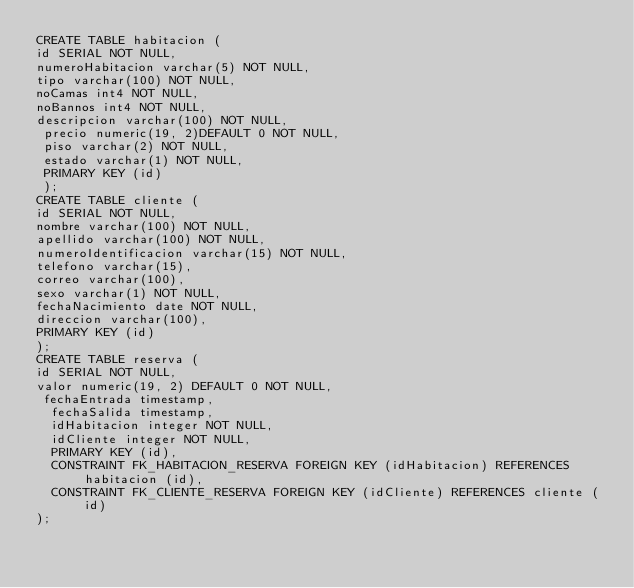<code> <loc_0><loc_0><loc_500><loc_500><_SQL_>CREATE TABLE habitacion (
id SERIAL NOT NULL,
numeroHabitacion varchar(5) NOT NULL,
tipo varchar(100) NOT NULL,
noCamas int4 NOT NULL,
noBannos int4 NOT NULL,
descripcion varchar(100) NOT NULL,
 precio numeric(19, 2)DEFAULT 0 NOT NULL,
 piso varchar(2) NOT NULL,
 estado varchar(1) NOT NULL,
 PRIMARY KEY (id)
 );
CREATE TABLE cliente (
id SERIAL NOT NULL,
nombre varchar(100) NOT NULL,
apellido varchar(100) NOT NULL,
numeroIdentificacion varchar(15) NOT NULL,
telefono varchar(15),
correo varchar(100),
sexo varchar(1) NOT NULL,
fechaNacimiento date NOT NULL,
direccion varchar(100),
PRIMARY KEY (id)
);
CREATE TABLE reserva (
id SERIAL NOT NULL,
valor numeric(19, 2) DEFAULT 0 NOT NULL,
 fechaEntrada timestamp,
  fechaSalida timestamp,
  idHabitacion integer NOT NULL,
  idCliente integer NOT NULL,
  PRIMARY KEY (id),
  CONSTRAINT FK_HABITACION_RESERVA FOREIGN KEY (idHabitacion) REFERENCES habitacion (id),
  CONSTRAINT FK_CLIENTE_RESERVA FOREIGN KEY (idCliente) REFERENCES cliente (id)
);



</code> 